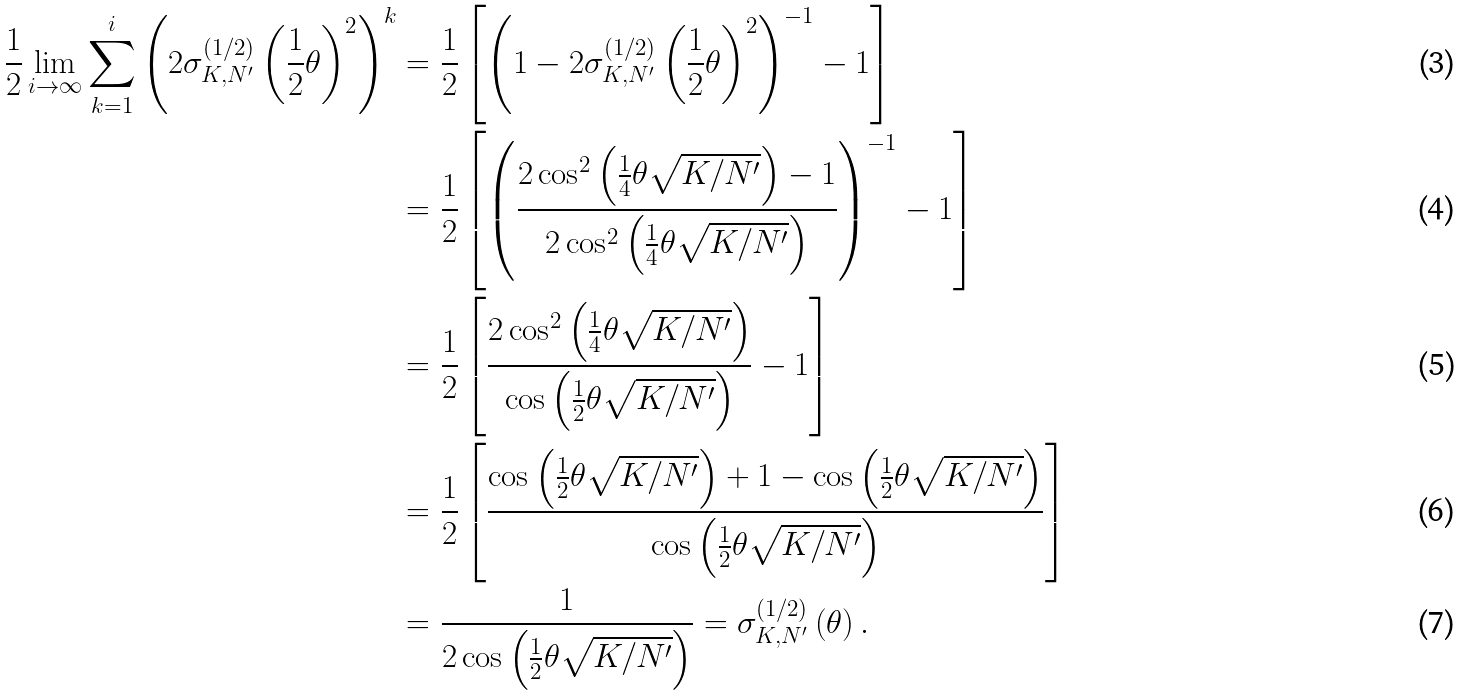<formula> <loc_0><loc_0><loc_500><loc_500>\frac { 1 } { 2 } \lim _ { i \to \infty } \sum ^ { i } _ { k = 1 } \left ( 2 \sigma ^ { ( 1 / 2 ) } _ { K , N ^ { \prime } } \left ( \frac { 1 } { 2 } \theta \right ) ^ { 2 } \right ) ^ { k } & = \frac { 1 } { 2 } \left [ \left ( 1 - 2 \sigma ^ { ( 1 / 2 ) } _ { K , N ^ { \prime } } \left ( \frac { 1 } { 2 } \theta \right ) ^ { 2 } \right ) ^ { - 1 } - 1 \right ] \\ & = \frac { 1 } { 2 } \left [ \left ( \frac { 2 \cos ^ { 2 } \left ( \frac { 1 } { 4 } \theta \sqrt { K / N ^ { \prime } } \right ) - 1 } { 2 \cos ^ { 2 } \left ( \frac { 1 } { 4 } \theta \sqrt { K / N ^ { \prime } } \right ) } \right ) ^ { - 1 } - 1 \right ] \\ & = \frac { 1 } { 2 } \left [ \frac { 2 \cos ^ { 2 } \left ( \frac { 1 } { 4 } \theta \sqrt { K / N ^ { \prime } } \right ) } { \cos \left ( \frac { 1 } { 2 } \theta \sqrt { K / N ^ { \prime } } \right ) } - 1 \right ] \\ & = \frac { 1 } { 2 } \left [ \frac { \cos \left ( \frac { 1 } { 2 } \theta \sqrt { K / N ^ { \prime } } \right ) + 1 - \cos \left ( \frac { 1 } { 2 } \theta \sqrt { K / N ^ { \prime } } \right ) } { \cos \left ( \frac { 1 } { 2 } \theta \sqrt { K / N ^ { \prime } } \right ) } \right ] \\ & = \frac { 1 } { 2 \cos \left ( \frac { 1 } { 2 } \theta \sqrt { K / N ^ { \prime } } \right ) } = \sigma ^ { ( 1 / 2 ) } _ { K , N ^ { \prime } } \left ( \theta \right ) .</formula> 